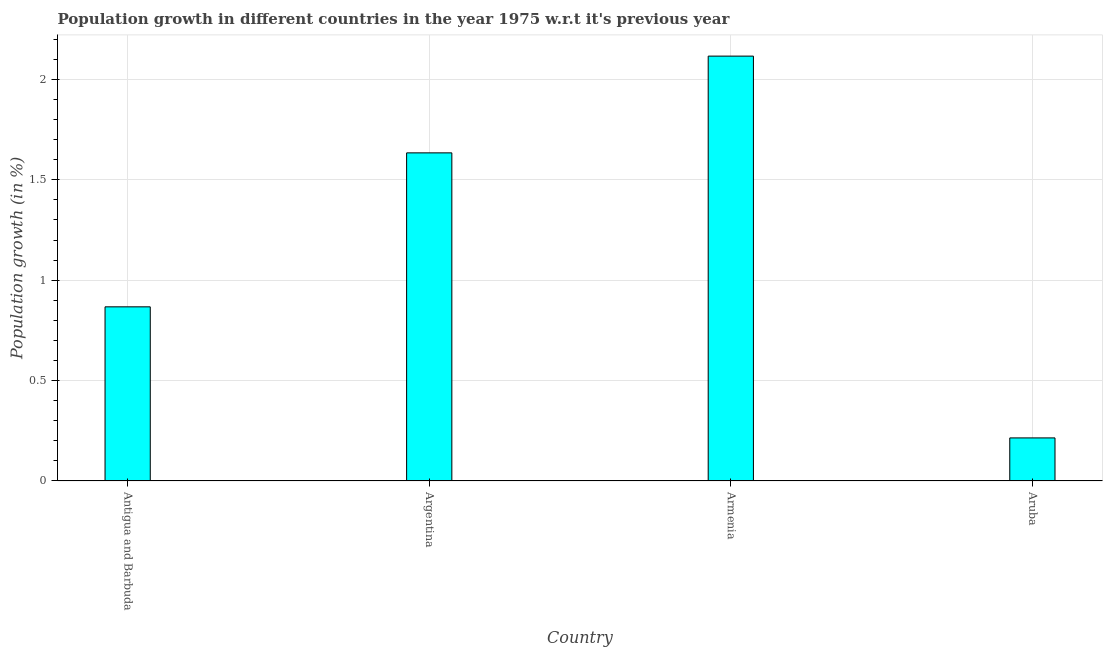Does the graph contain any zero values?
Your answer should be very brief. No. Does the graph contain grids?
Ensure brevity in your answer.  Yes. What is the title of the graph?
Your response must be concise. Population growth in different countries in the year 1975 w.r.t it's previous year. What is the label or title of the Y-axis?
Provide a succinct answer. Population growth (in %). What is the population growth in Antigua and Barbuda?
Give a very brief answer. 0.87. Across all countries, what is the maximum population growth?
Keep it short and to the point. 2.12. Across all countries, what is the minimum population growth?
Ensure brevity in your answer.  0.21. In which country was the population growth maximum?
Your answer should be very brief. Armenia. In which country was the population growth minimum?
Ensure brevity in your answer.  Aruba. What is the sum of the population growth?
Your answer should be compact. 4.83. What is the difference between the population growth in Armenia and Aruba?
Offer a very short reply. 1.9. What is the average population growth per country?
Your answer should be very brief. 1.21. What is the median population growth?
Give a very brief answer. 1.25. In how many countries, is the population growth greater than 1.6 %?
Give a very brief answer. 2. What is the ratio of the population growth in Antigua and Barbuda to that in Argentina?
Offer a very short reply. 0.53. Is the population growth in Antigua and Barbuda less than that in Armenia?
Keep it short and to the point. Yes. What is the difference between the highest and the second highest population growth?
Make the answer very short. 0.48. What is the difference between the highest and the lowest population growth?
Offer a very short reply. 1.9. How many bars are there?
Make the answer very short. 4. How many countries are there in the graph?
Make the answer very short. 4. Are the values on the major ticks of Y-axis written in scientific E-notation?
Ensure brevity in your answer.  No. What is the Population growth (in %) of Antigua and Barbuda?
Provide a short and direct response. 0.87. What is the Population growth (in %) in Argentina?
Ensure brevity in your answer.  1.63. What is the Population growth (in %) in Armenia?
Offer a very short reply. 2.12. What is the Population growth (in %) of Aruba?
Your response must be concise. 0.21. What is the difference between the Population growth (in %) in Antigua and Barbuda and Argentina?
Offer a terse response. -0.77. What is the difference between the Population growth (in %) in Antigua and Barbuda and Armenia?
Ensure brevity in your answer.  -1.25. What is the difference between the Population growth (in %) in Antigua and Barbuda and Aruba?
Give a very brief answer. 0.65. What is the difference between the Population growth (in %) in Argentina and Armenia?
Your answer should be compact. -0.48. What is the difference between the Population growth (in %) in Argentina and Aruba?
Give a very brief answer. 1.42. What is the difference between the Population growth (in %) in Armenia and Aruba?
Keep it short and to the point. 1.9. What is the ratio of the Population growth (in %) in Antigua and Barbuda to that in Argentina?
Offer a very short reply. 0.53. What is the ratio of the Population growth (in %) in Antigua and Barbuda to that in Armenia?
Your response must be concise. 0.41. What is the ratio of the Population growth (in %) in Antigua and Barbuda to that in Aruba?
Provide a short and direct response. 4.04. What is the ratio of the Population growth (in %) in Argentina to that in Armenia?
Provide a short and direct response. 0.77. What is the ratio of the Population growth (in %) in Argentina to that in Aruba?
Provide a short and direct response. 7.62. What is the ratio of the Population growth (in %) in Armenia to that in Aruba?
Give a very brief answer. 9.86. 